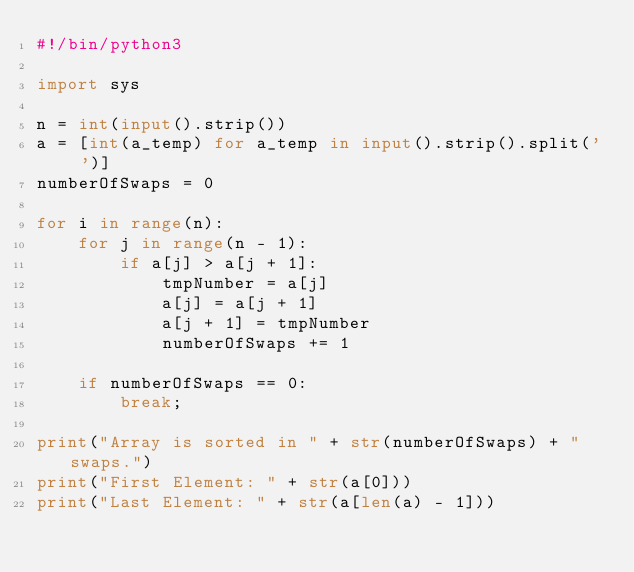<code> <loc_0><loc_0><loc_500><loc_500><_Python_>#!/bin/python3

import sys

n = int(input().strip())
a = [int(a_temp) for a_temp in input().strip().split(' ')]
numberOfSwaps = 0

for i in range(n):
    for j in range(n - 1):
        if a[j] > a[j + 1]:
            tmpNumber = a[j]
            a[j] = a[j + 1]
            a[j + 1] = tmpNumber
            numberOfSwaps += 1

    if numberOfSwaps == 0:
        break;

print("Array is sorted in " + str(numberOfSwaps) + " swaps.")
print("First Element: " + str(a[0]))
print("Last Element: " + str(a[len(a) - 1]))</code> 